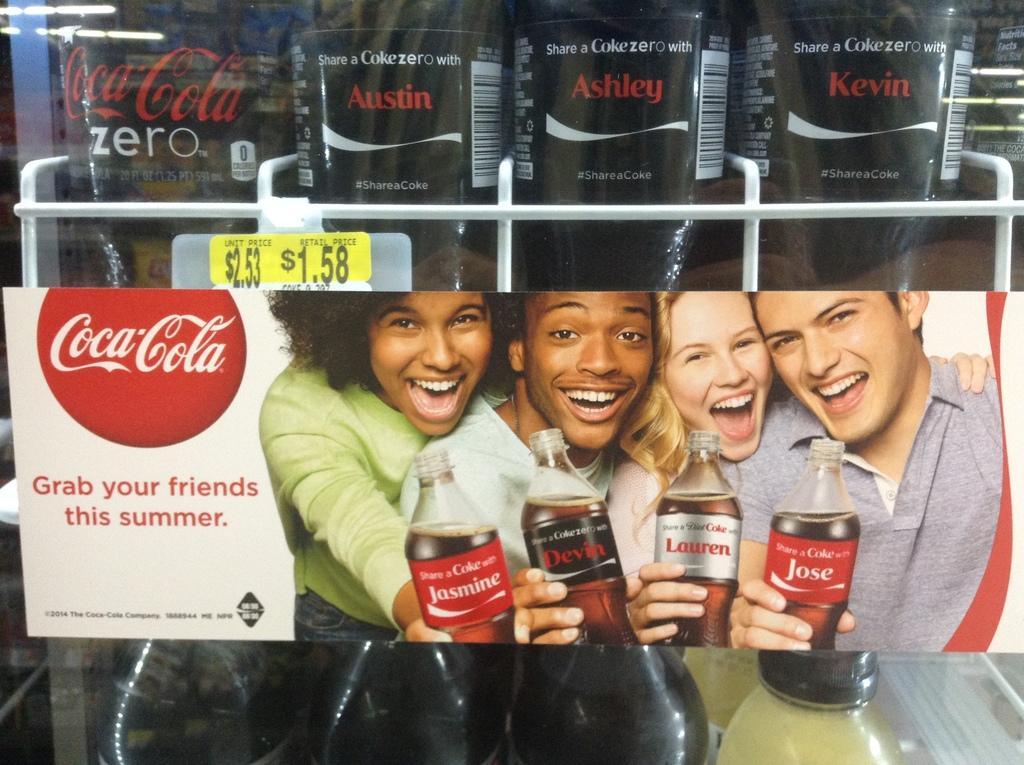In one or two sentences, can you explain what this image depicts? In this image I can see few people are holding bottles, I can also see a smile on their faces. 